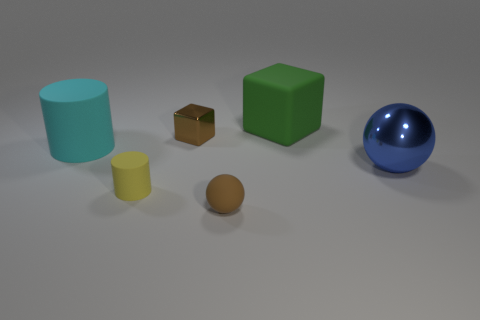Add 1 big green matte objects. How many objects exist? 7 Subtract all matte cubes. Subtract all brown balls. How many objects are left? 4 Add 5 small rubber balls. How many small rubber balls are left? 6 Add 5 big rubber cubes. How many big rubber cubes exist? 6 Subtract 0 blue cylinders. How many objects are left? 6 Subtract all cylinders. How many objects are left? 4 